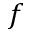<formula> <loc_0><loc_0><loc_500><loc_500>f</formula> 